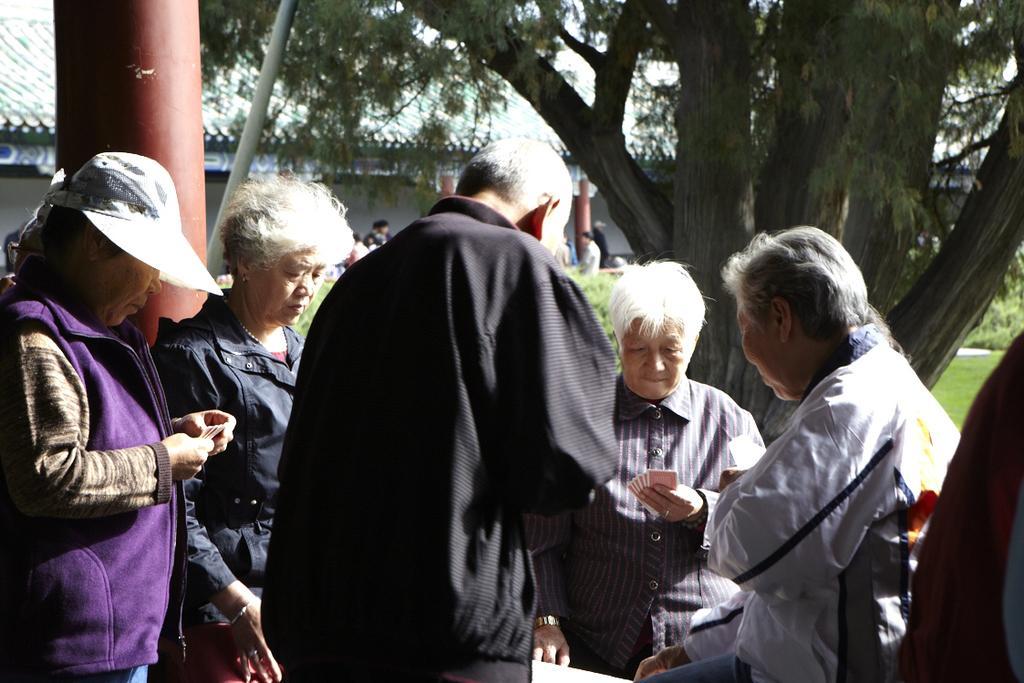Could you give a brief overview of what you see in this image? This picture is clicked outside. In the foreground we can see the group of people and in the background we can see the houses, trees, metal rod and the group of people and we can see the plants and the green grass and some other objects. 